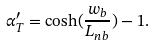<formula> <loc_0><loc_0><loc_500><loc_500>\alpha _ { T } ^ { \prime } = \cosh ( \frac { w _ { b } } { L _ { n b } } ) - 1 .</formula> 